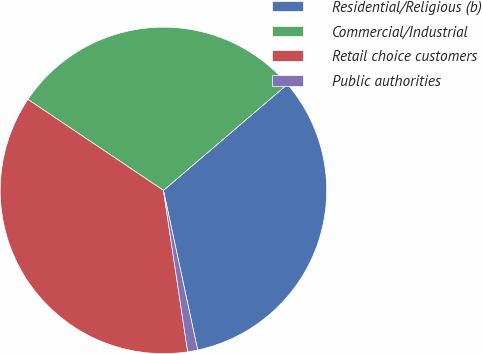<chart> <loc_0><loc_0><loc_500><loc_500><pie_chart><fcel>Residential/Religious (b)<fcel>Commercial/Industrial<fcel>Retail choice customers<fcel>Public authorities<nl><fcel>32.9%<fcel>29.32%<fcel>36.78%<fcel>0.99%<nl></chart> 